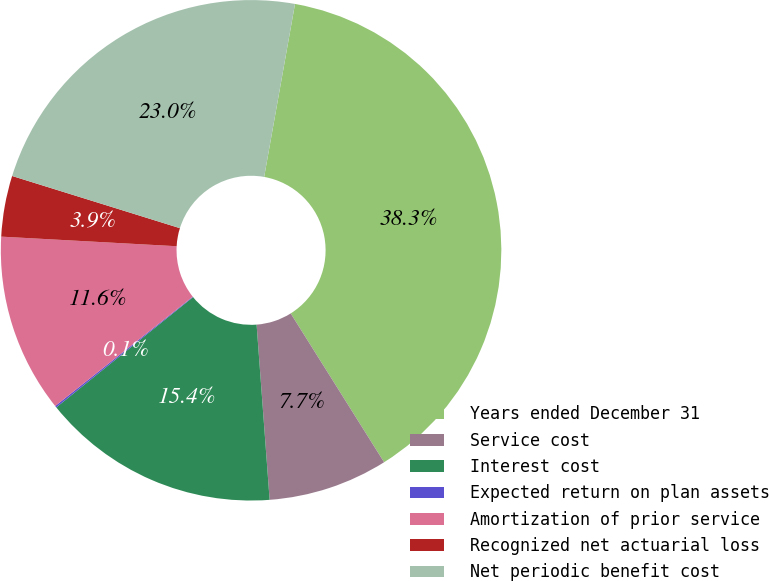Convert chart to OTSL. <chart><loc_0><loc_0><loc_500><loc_500><pie_chart><fcel>Years ended December 31<fcel>Service cost<fcel>Interest cost<fcel>Expected return on plan assets<fcel>Amortization of prior service<fcel>Recognized net actuarial loss<fcel>Net periodic benefit cost<nl><fcel>38.27%<fcel>7.74%<fcel>15.38%<fcel>0.11%<fcel>11.56%<fcel>3.93%<fcel>23.01%<nl></chart> 